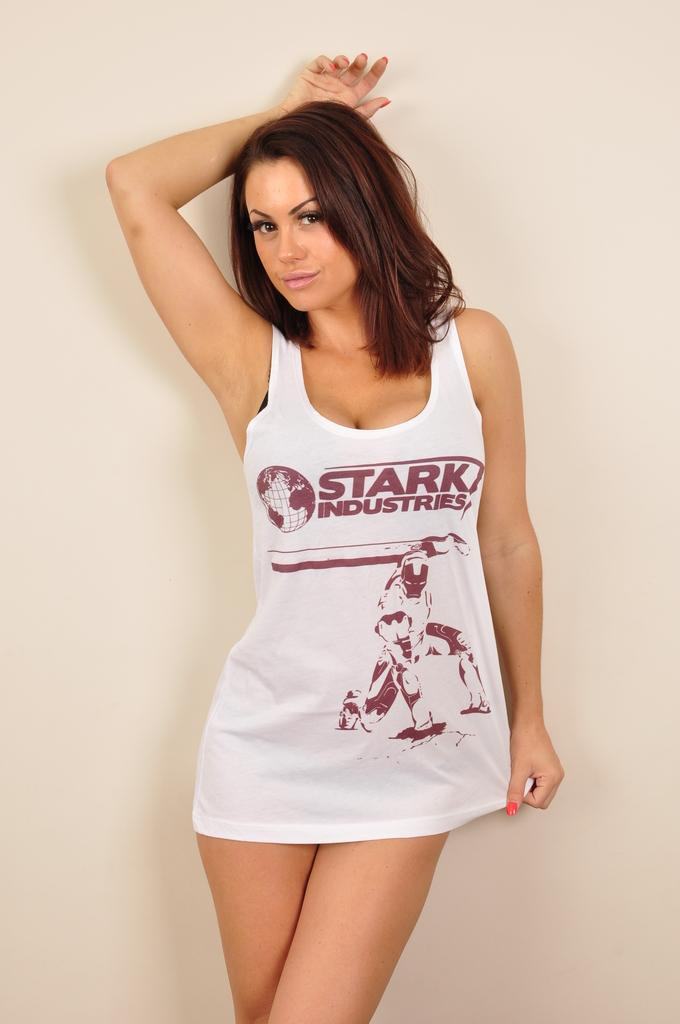<image>
Write a terse but informative summary of the picture. On the front of the girls shirt it reads STARK INDUSTRIES. 